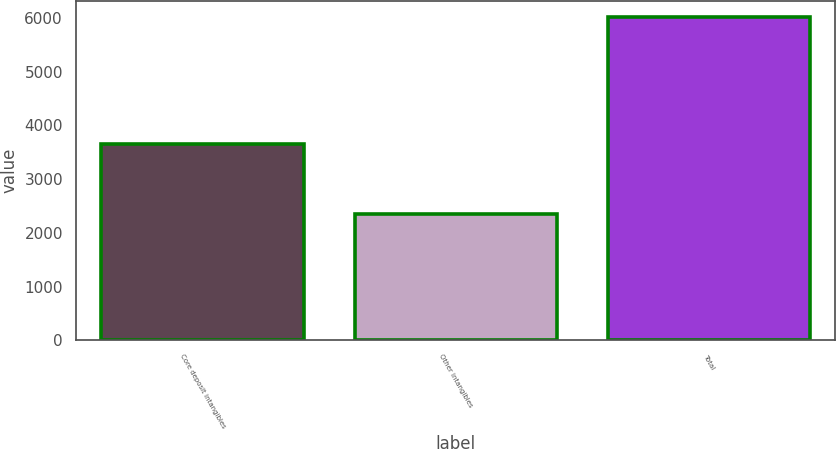Convert chart to OTSL. <chart><loc_0><loc_0><loc_500><loc_500><bar_chart><fcel>Core deposit intangibles<fcel>Other intangibles<fcel>Total<nl><fcel>3661<fcel>2353<fcel>6014<nl></chart> 